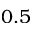Convert formula to latex. <formula><loc_0><loc_0><loc_500><loc_500>0 . 5</formula> 